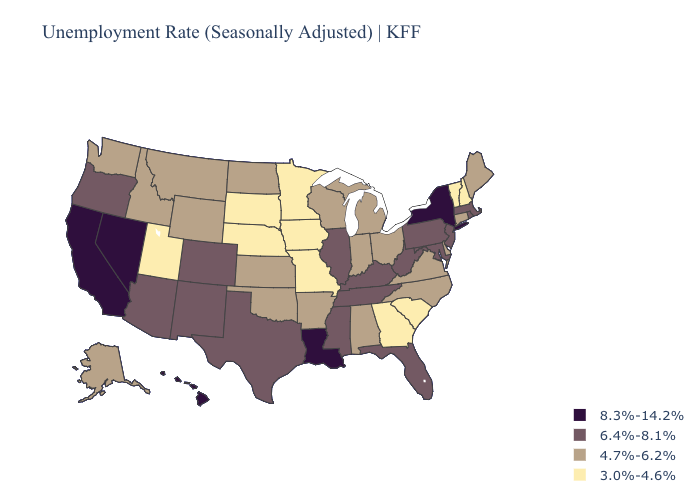Which states hav the highest value in the South?
Quick response, please. Louisiana. What is the value of California?
Quick response, please. 8.3%-14.2%. Does Wyoming have the lowest value in the USA?
Write a very short answer. No. Does Oklahoma have the highest value in the South?
Write a very short answer. No. What is the value of Ohio?
Short answer required. 4.7%-6.2%. Does South Dakota have the lowest value in the USA?
Write a very short answer. Yes. What is the value of Michigan?
Write a very short answer. 4.7%-6.2%. Name the states that have a value in the range 6.4%-8.1%?
Be succinct. Arizona, Colorado, Florida, Illinois, Kentucky, Maryland, Massachusetts, Mississippi, New Jersey, New Mexico, Oregon, Pennsylvania, Rhode Island, Tennessee, Texas, West Virginia. Name the states that have a value in the range 6.4%-8.1%?
Concise answer only. Arizona, Colorado, Florida, Illinois, Kentucky, Maryland, Massachusetts, Mississippi, New Jersey, New Mexico, Oregon, Pennsylvania, Rhode Island, Tennessee, Texas, West Virginia. Is the legend a continuous bar?
Be succinct. No. What is the value of Pennsylvania?
Answer briefly. 6.4%-8.1%. Does North Carolina have the highest value in the USA?
Be succinct. No. What is the highest value in the USA?
Answer briefly. 8.3%-14.2%. Name the states that have a value in the range 3.0%-4.6%?
Quick response, please. Georgia, Iowa, Minnesota, Missouri, Nebraska, New Hampshire, South Carolina, South Dakota, Utah, Vermont. How many symbols are there in the legend?
Write a very short answer. 4. 